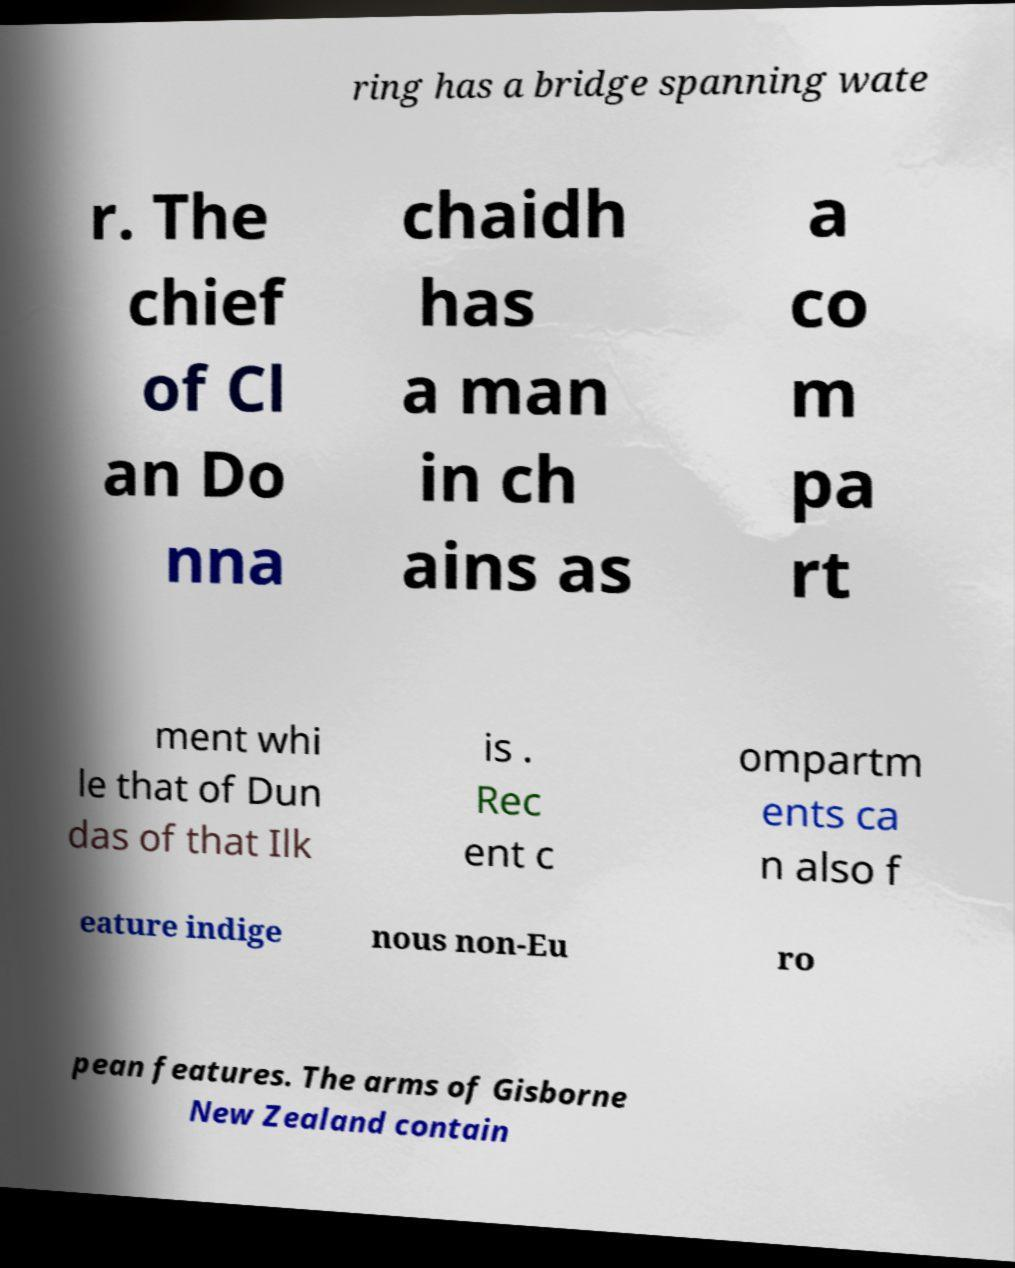Please read and relay the text visible in this image. What does it say? ring has a bridge spanning wate r. The chief of Cl an Do nna chaidh has a man in ch ains as a co m pa rt ment whi le that of Dun das of that Ilk is . Rec ent c ompartm ents ca n also f eature indige nous non-Eu ro pean features. The arms of Gisborne New Zealand contain 